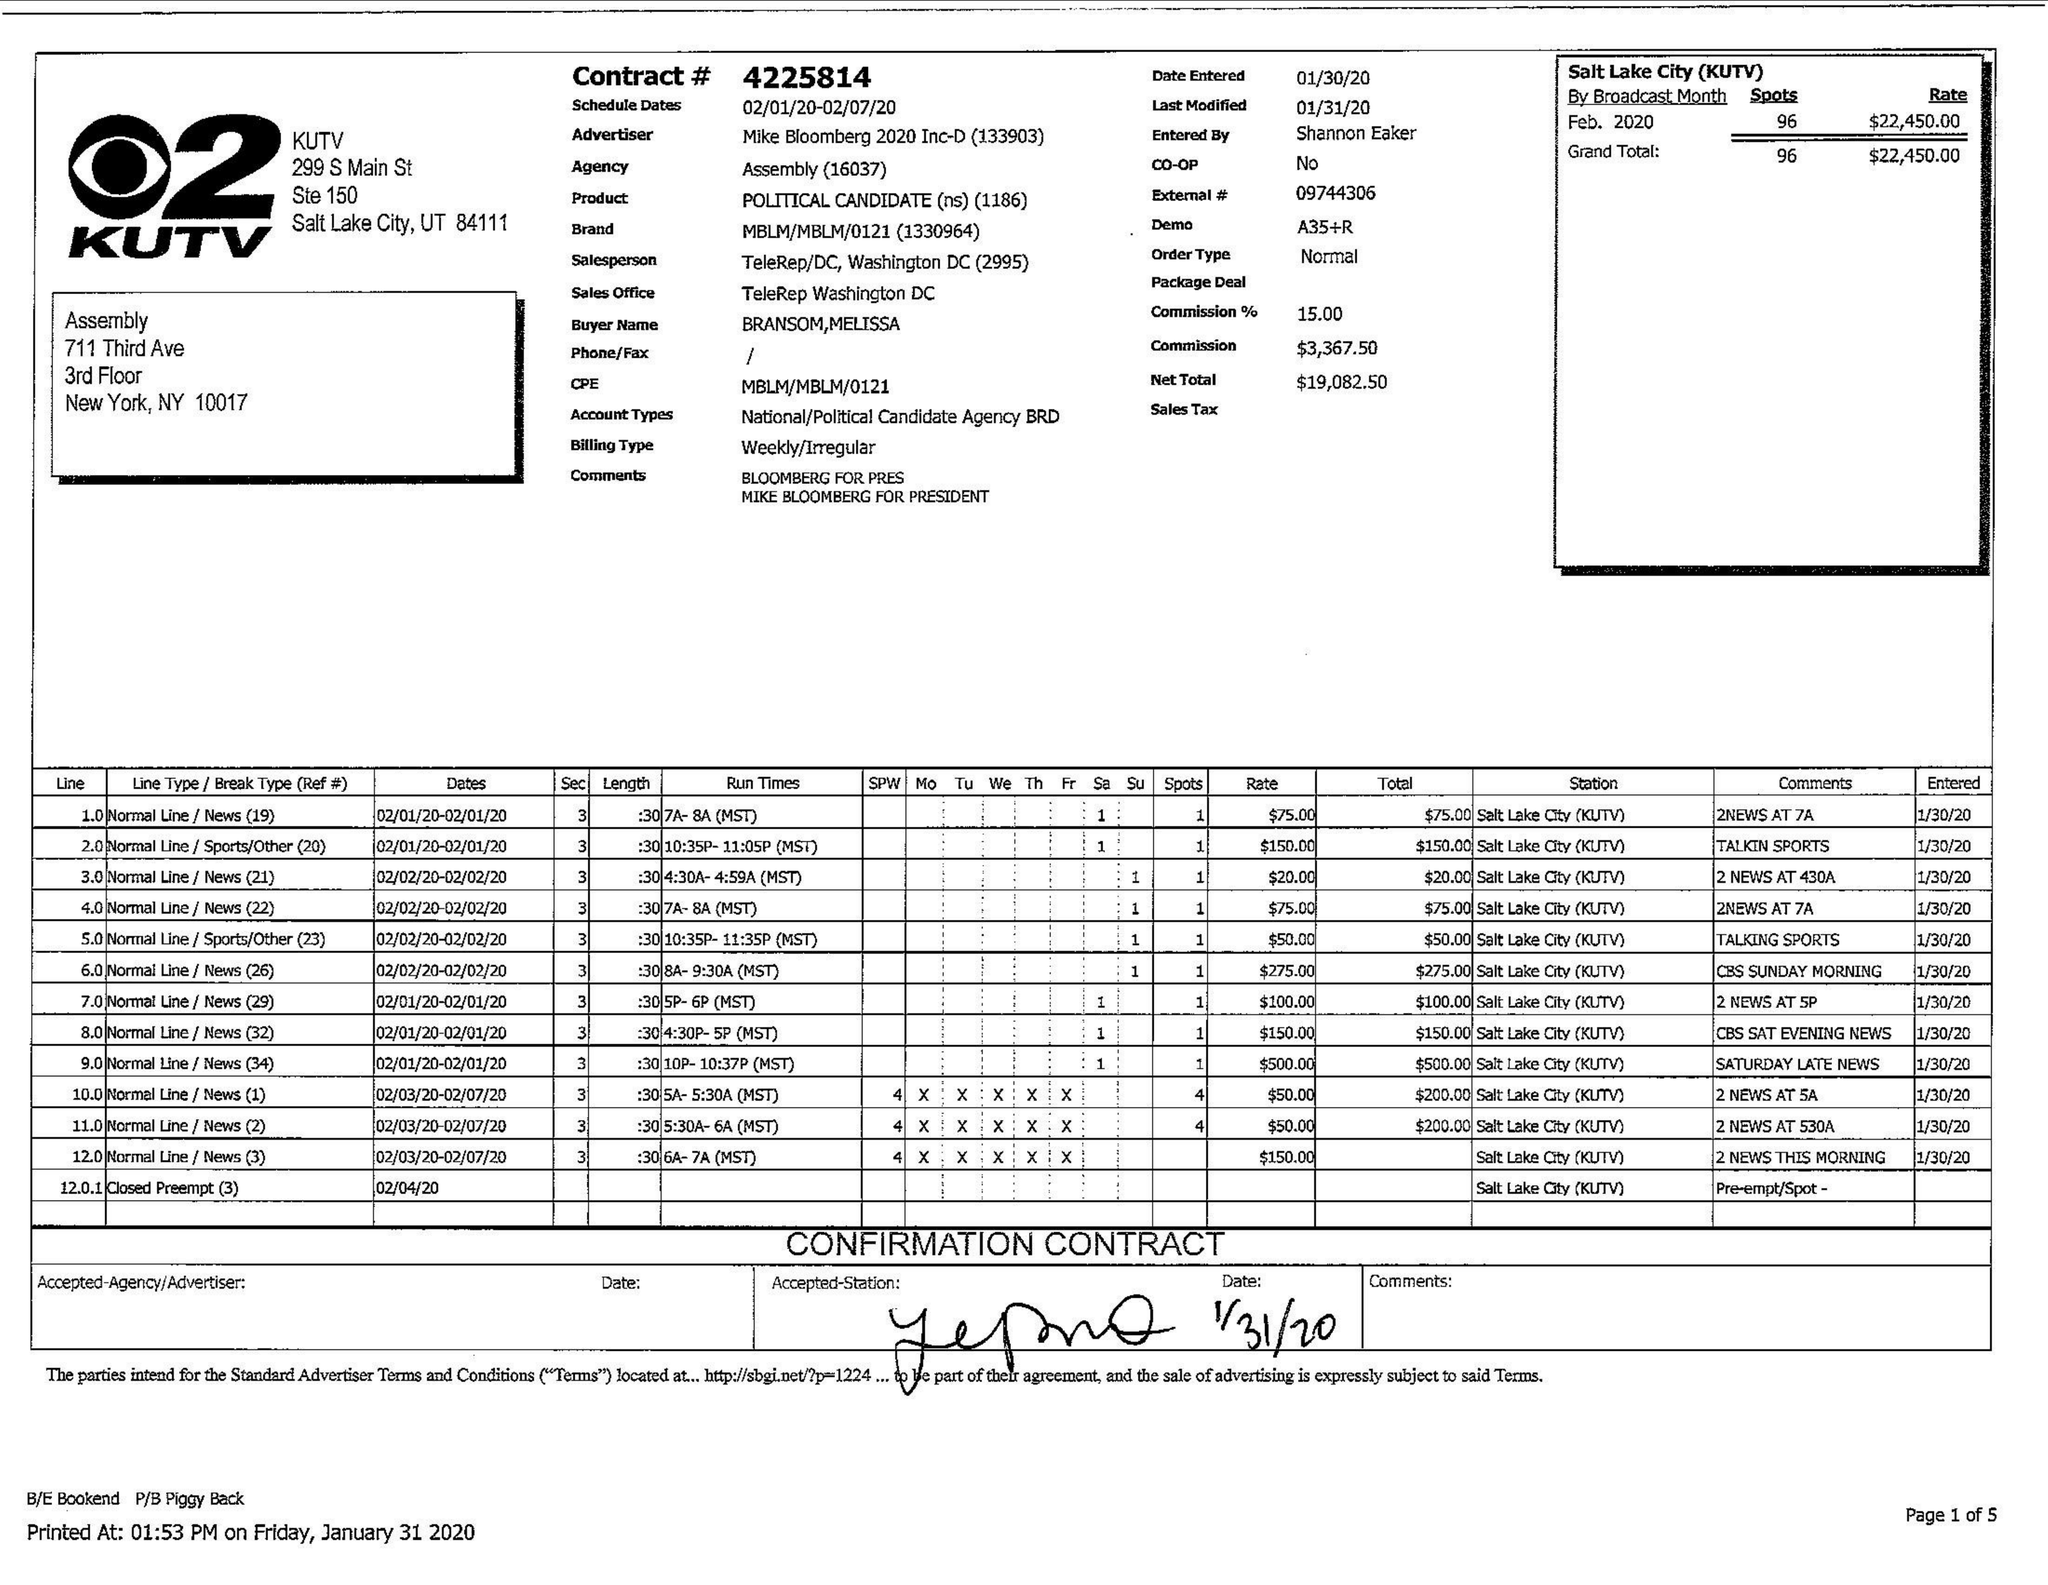What is the value for the gross_amount?
Answer the question using a single word or phrase. 22450.00 